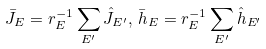Convert formula to latex. <formula><loc_0><loc_0><loc_500><loc_500>\bar { J } _ { E } = r _ { E } ^ { - 1 } \sum _ { E ^ { \prime } } \hat { J } _ { E ^ { \prime } } , \, \bar { h } _ { E } = r _ { E } ^ { - 1 } \sum _ { E ^ { \prime } } \hat { h } _ { E ^ { \prime } }</formula> 